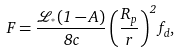<formula> <loc_0><loc_0><loc_500><loc_500>F = \frac { \mathcal { L } _ { ^ { * } } ( 1 - A ) } { 8 c } \left ( \frac { R _ { p } } { r } \right ) ^ { 2 } f _ { d } ,</formula> 